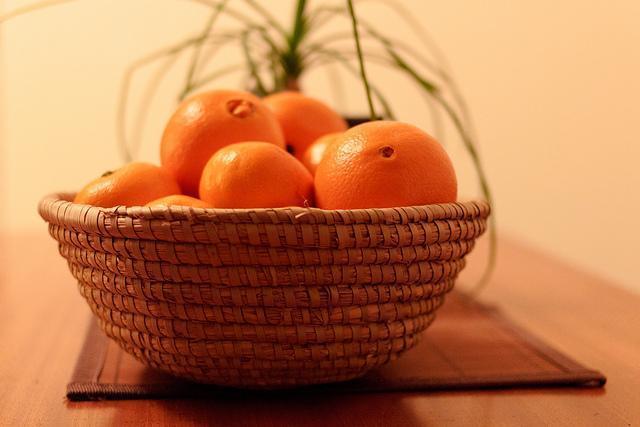How many oranges can you see?
Give a very brief answer. 2. 